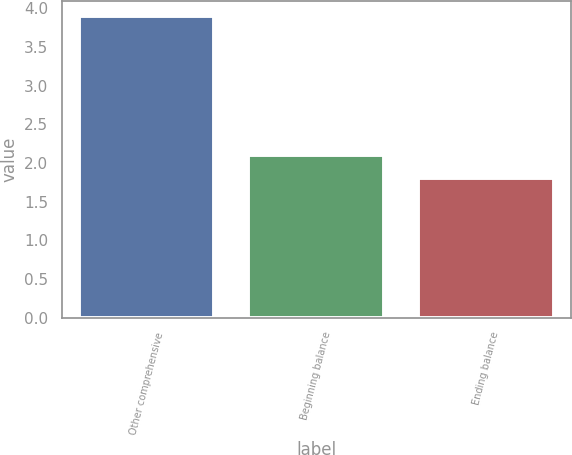<chart> <loc_0><loc_0><loc_500><loc_500><bar_chart><fcel>Other comprehensive<fcel>Beginning balance<fcel>Ending balance<nl><fcel>3.9<fcel>2.1<fcel>1.8<nl></chart> 